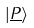Convert formula to latex. <formula><loc_0><loc_0><loc_500><loc_500>| \underline { P } \rangle</formula> 